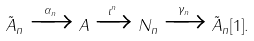<formula> <loc_0><loc_0><loc_500><loc_500>\tilde { A } _ { n } \xrightarrow { \alpha _ { n } } A \xrightarrow { \iota ^ { n } } N _ { n } \xrightarrow { \gamma _ { n } } \tilde { A } _ { n } [ 1 ] .</formula> 